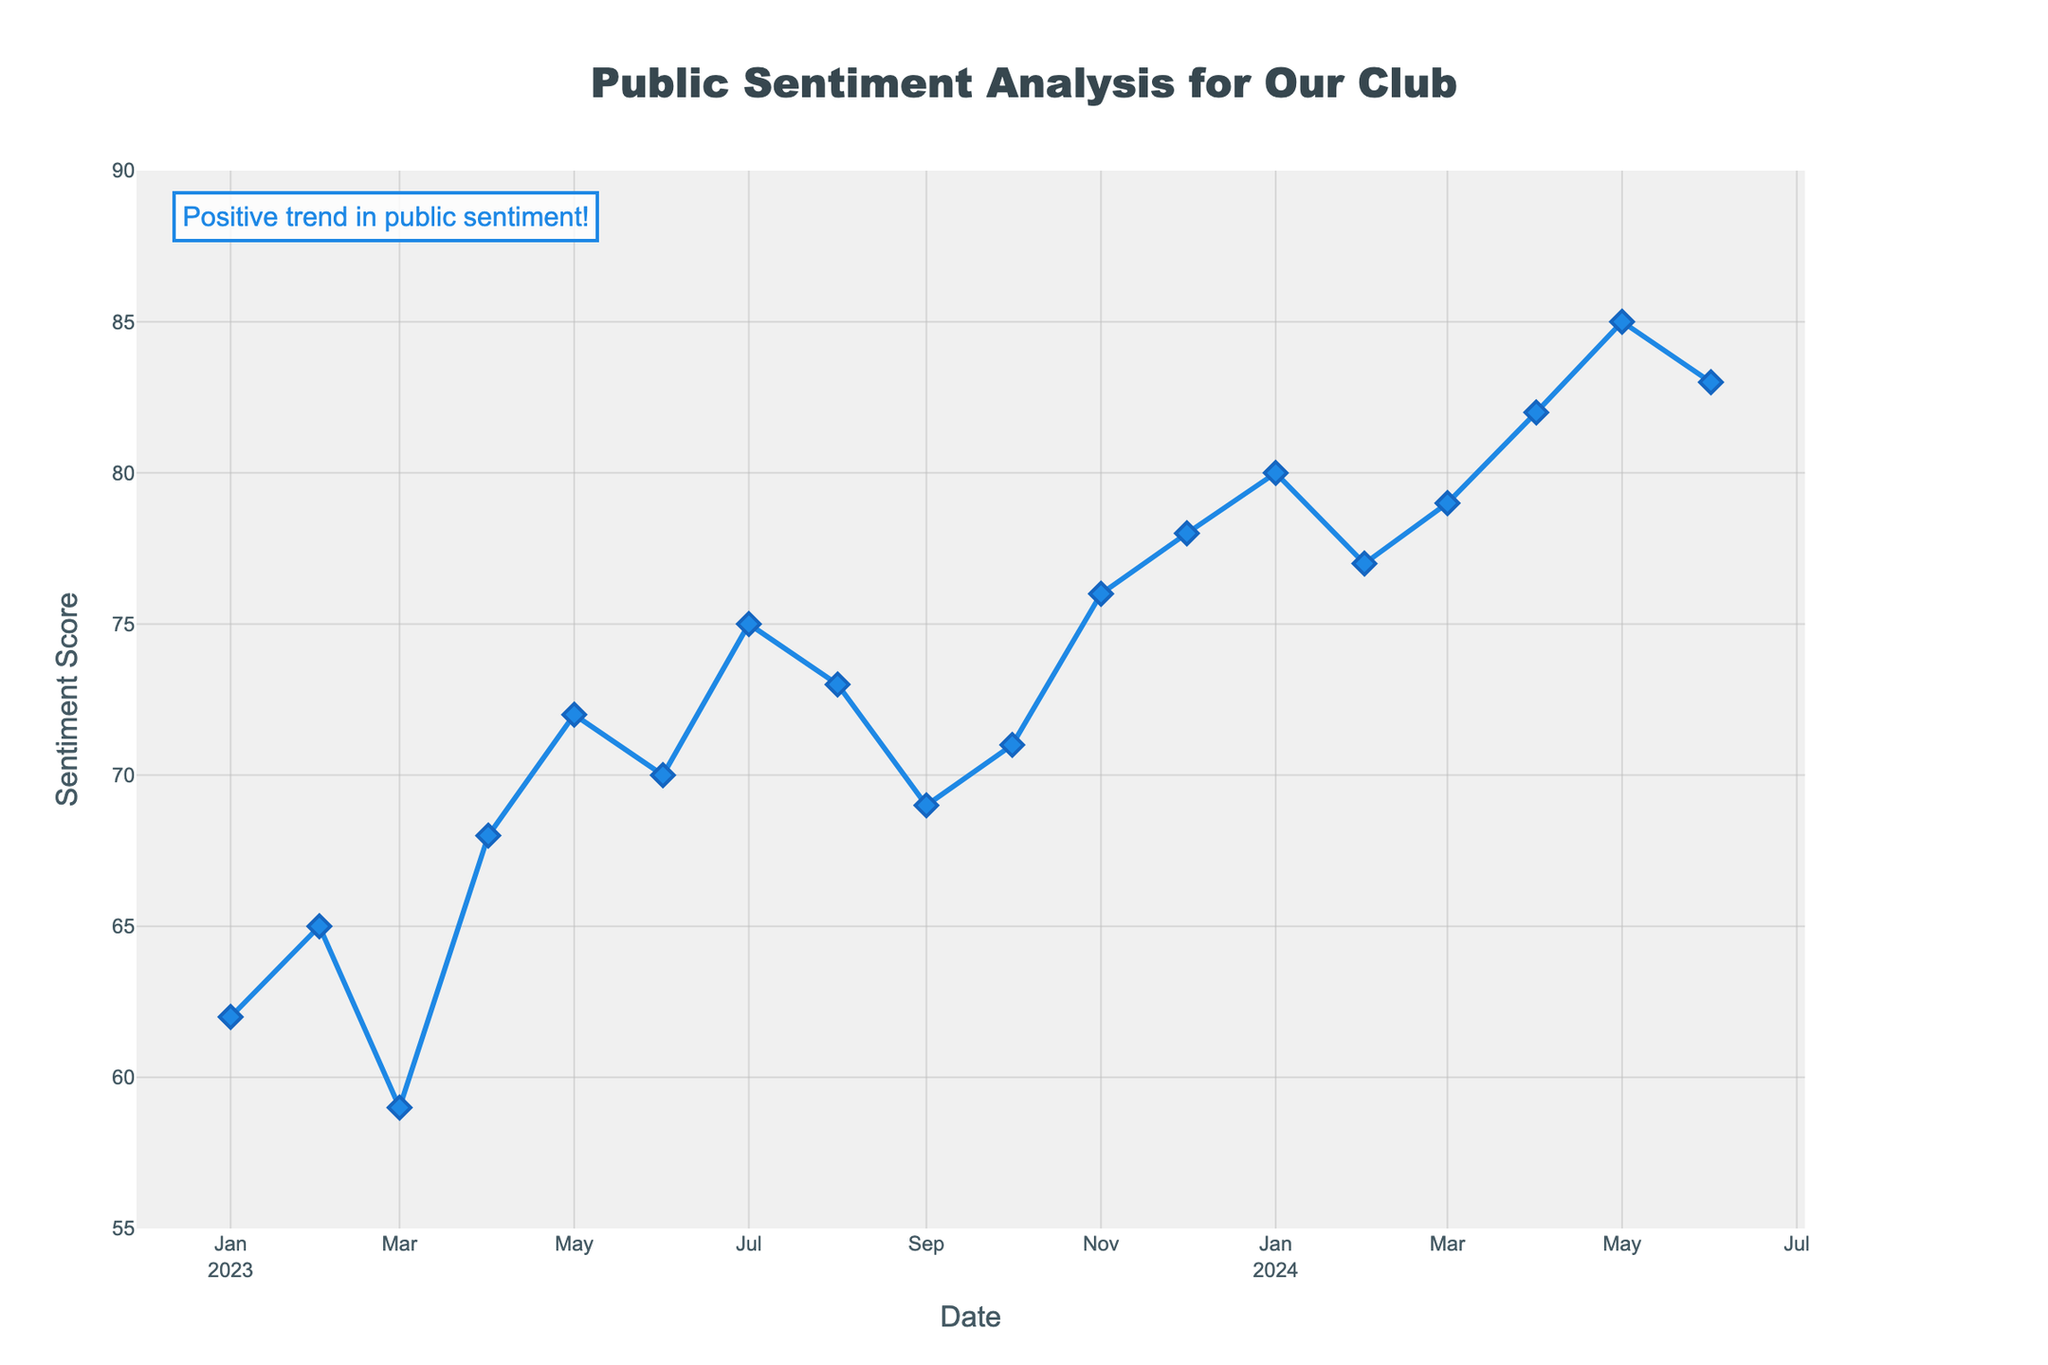What's the general trend in public sentiment from January 2023 to June 2024? The sentiment scores generally increase over the period from January 2023 to June 2024. Starting from a score of 62 in January 2023, the sentiment rises to 85 by June 2024, indicating an overall positive trend.
Answer: Positive What is the highest sentiment score recorded, and in which month did it occur? The highest sentiment score recorded is 85, which occurred in May 2024. This is discerned by identifying the peak value in the visible data points.
Answer: 85 in May 2024 How does the sentiment score in June 2023 compare to January 2024? The sentiment score in June 2023 is 70, while it is 80 in January 2024. By comparing these two values, we see that the sentiment increased by 10 points over this period.
Answer: Increased by 10 points What is the average sentiment score between January 2023 and June 2024? There are 18 months in the date range provided. Summing up all sentiment scores: 62 + 65 + 59 + 68 + 72 + 70 + 75 + 73 + 69 + 71 + 76 + 78 + 80 + 77 + 79 + 82 + 85 + 83 = 1244. Divide by 18 to find the average: 1244 / 18 ≈ 69.11.
Answer: Approximately 69.11 Which month shows the largest increase in sentiment score compared to the previous month? By evaluating the differences between consecutive months, the largest increase is noticed from April 2024 (82) to May 2024 (85), which is an increase of 3 points.
Answer: May 2024 Between which two consecutive months is there the largest drop in sentiment score? Evaluating the differences between consecutive months shows the largest drop is from February 2024 (77) to March 2024 (79), a decrease of 3 points.
Answer: February 2024 to March 2024 Describe the annotation on the chart. The annotation on the chart is a text stating "Positive trend in public sentiment!" placed near the top-left corner. It has a light background, blue border, and emphasizes the positive overall trend.
Answer: "Positive trend in public sentiment!" near top-left What specific visual elements are used to represent the sentiment scores on the plot? Sentiment scores are represented using blue lines connecting diamond-shaped markers. Additionally, hover information provides detailed date and score data.
Answer: Blue lines and diamond markers with hover info What pattern is observed in the scores from November 2023 to February 2024? The sentiment scores steadily increase from November 2023 (76) to January 2024 (80), then slightly drop in February 2024 (77).
Answer: Increase then slight drop Is there any period where the sentiment scores plateau or remain consistent for more than two consecutive months? No period shows a complete plateau or consistent scores for more than two consecutive months; the sentiment scores either increase or decrease each month.
Answer: No plateau 